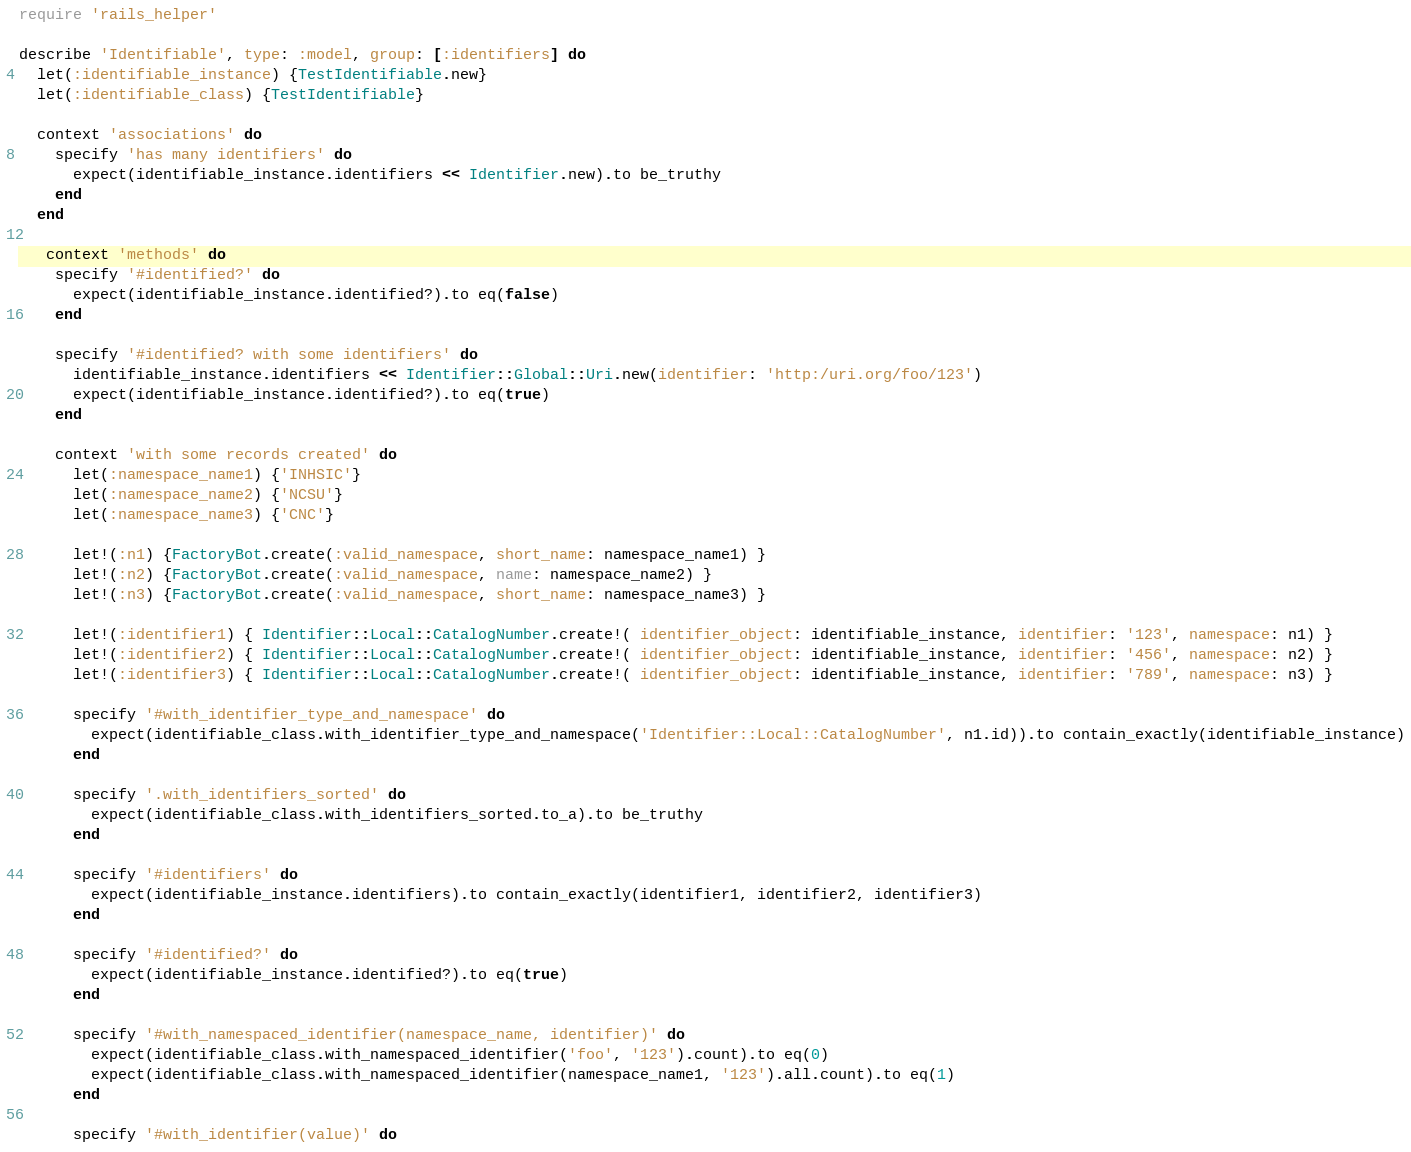<code> <loc_0><loc_0><loc_500><loc_500><_Ruby_>require 'rails_helper'

describe 'Identifiable', type: :model, group: [:identifiers] do
  let(:identifiable_instance) {TestIdentifiable.new}
  let(:identifiable_class) {TestIdentifiable}

  context 'associations' do
    specify 'has many identifiers' do
      expect(identifiable_instance.identifiers << Identifier.new).to be_truthy
    end
  end

   context 'methods' do
    specify '#identified?' do
      expect(identifiable_instance.identified?).to eq(false)
    end

    specify '#identified? with some identifiers' do
      identifiable_instance.identifiers << Identifier::Global::Uri.new(identifier: 'http:/uri.org/foo/123')
      expect(identifiable_instance.identified?).to eq(true)
    end

    context 'with some records created' do
      let(:namespace_name1) {'INHSIC'}
      let(:namespace_name2) {'NCSU'}
      let(:namespace_name3) {'CNC'}

      let!(:n1) {FactoryBot.create(:valid_namespace, short_name: namespace_name1) }
      let!(:n2) {FactoryBot.create(:valid_namespace, name: namespace_name2) }
      let!(:n3) {FactoryBot.create(:valid_namespace, short_name: namespace_name3) }

      let!(:identifier1) { Identifier::Local::CatalogNumber.create!( identifier_object: identifiable_instance, identifier: '123', namespace: n1) }
      let!(:identifier2) { Identifier::Local::CatalogNumber.create!( identifier_object: identifiable_instance, identifier: '456', namespace: n2) }
      let!(:identifier3) { Identifier::Local::CatalogNumber.create!( identifier_object: identifiable_instance, identifier: '789', namespace: n3) }

      specify '#with_identifier_type_and_namespace' do
        expect(identifiable_class.with_identifier_type_and_namespace('Identifier::Local::CatalogNumber', n1.id)).to contain_exactly(identifiable_instance)
      end

      specify '.with_identifiers_sorted' do
        expect(identifiable_class.with_identifiers_sorted.to_a).to be_truthy
      end

      specify '#identifiers' do
        expect(identifiable_instance.identifiers).to contain_exactly(identifier1, identifier2, identifier3)
      end

      specify '#identified?' do
        expect(identifiable_instance.identified?).to eq(true)
      end

      specify '#with_namespaced_identifier(namespace_name, identifier)' do
        expect(identifiable_class.with_namespaced_identifier('foo', '123').count).to eq(0)
        expect(identifiable_class.with_namespaced_identifier(namespace_name1, '123').all.count).to eq(1)
      end

      specify '#with_identifier(value)' do</code> 